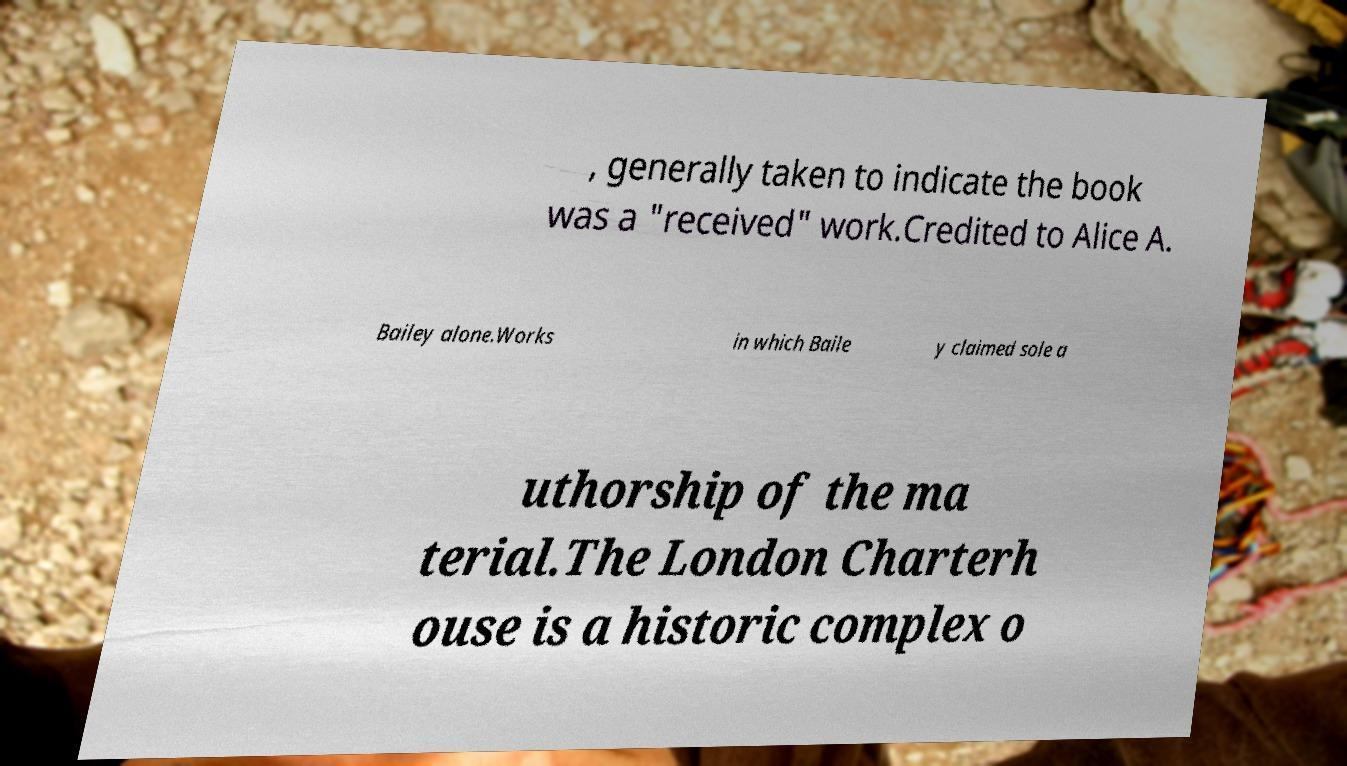There's text embedded in this image that I need extracted. Can you transcribe it verbatim? , generally taken to indicate the book was a "received" work.Credited to Alice A. Bailey alone.Works in which Baile y claimed sole a uthorship of the ma terial.The London Charterh ouse is a historic complex o 